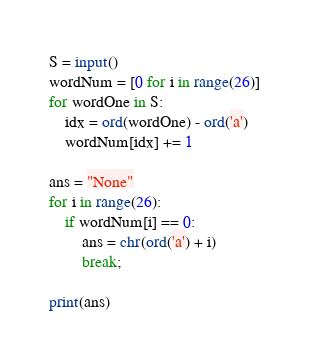<code> <loc_0><loc_0><loc_500><loc_500><_Python_>S = input()
wordNum = [0 for i in range(26)]
for wordOne in S:
    idx = ord(wordOne) - ord('a')
    wordNum[idx] += 1

ans = "None"
for i in range(26):
    if wordNum[i] == 0:
        ans = chr(ord('a') + i)
        break;

print(ans)

</code> 